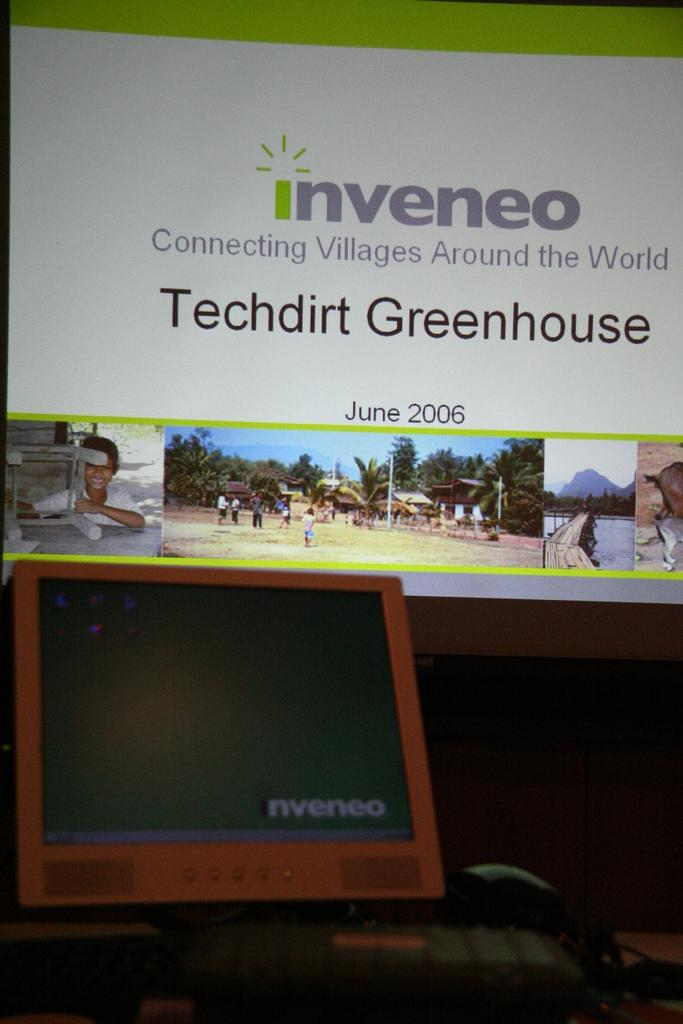What electronic device is present in the image? There is a monitor in the image. What is used for input with the monitor? There is a keyboard in the image. Are there any visible connections in the image? Yes, there are wires visible in the image. Where are these items located? They are on a table. What can be seen on the display screen in the background? The display screen contains pictures and text. How many teeth does the mother have in the image? There is no mother present in the image, and therefore no teeth to count. What type of division is being performed on the display screen? There is no division being performed on the display screen; it contains pictures and text. 